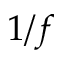<formula> <loc_0><loc_0><loc_500><loc_500>1 / f</formula> 